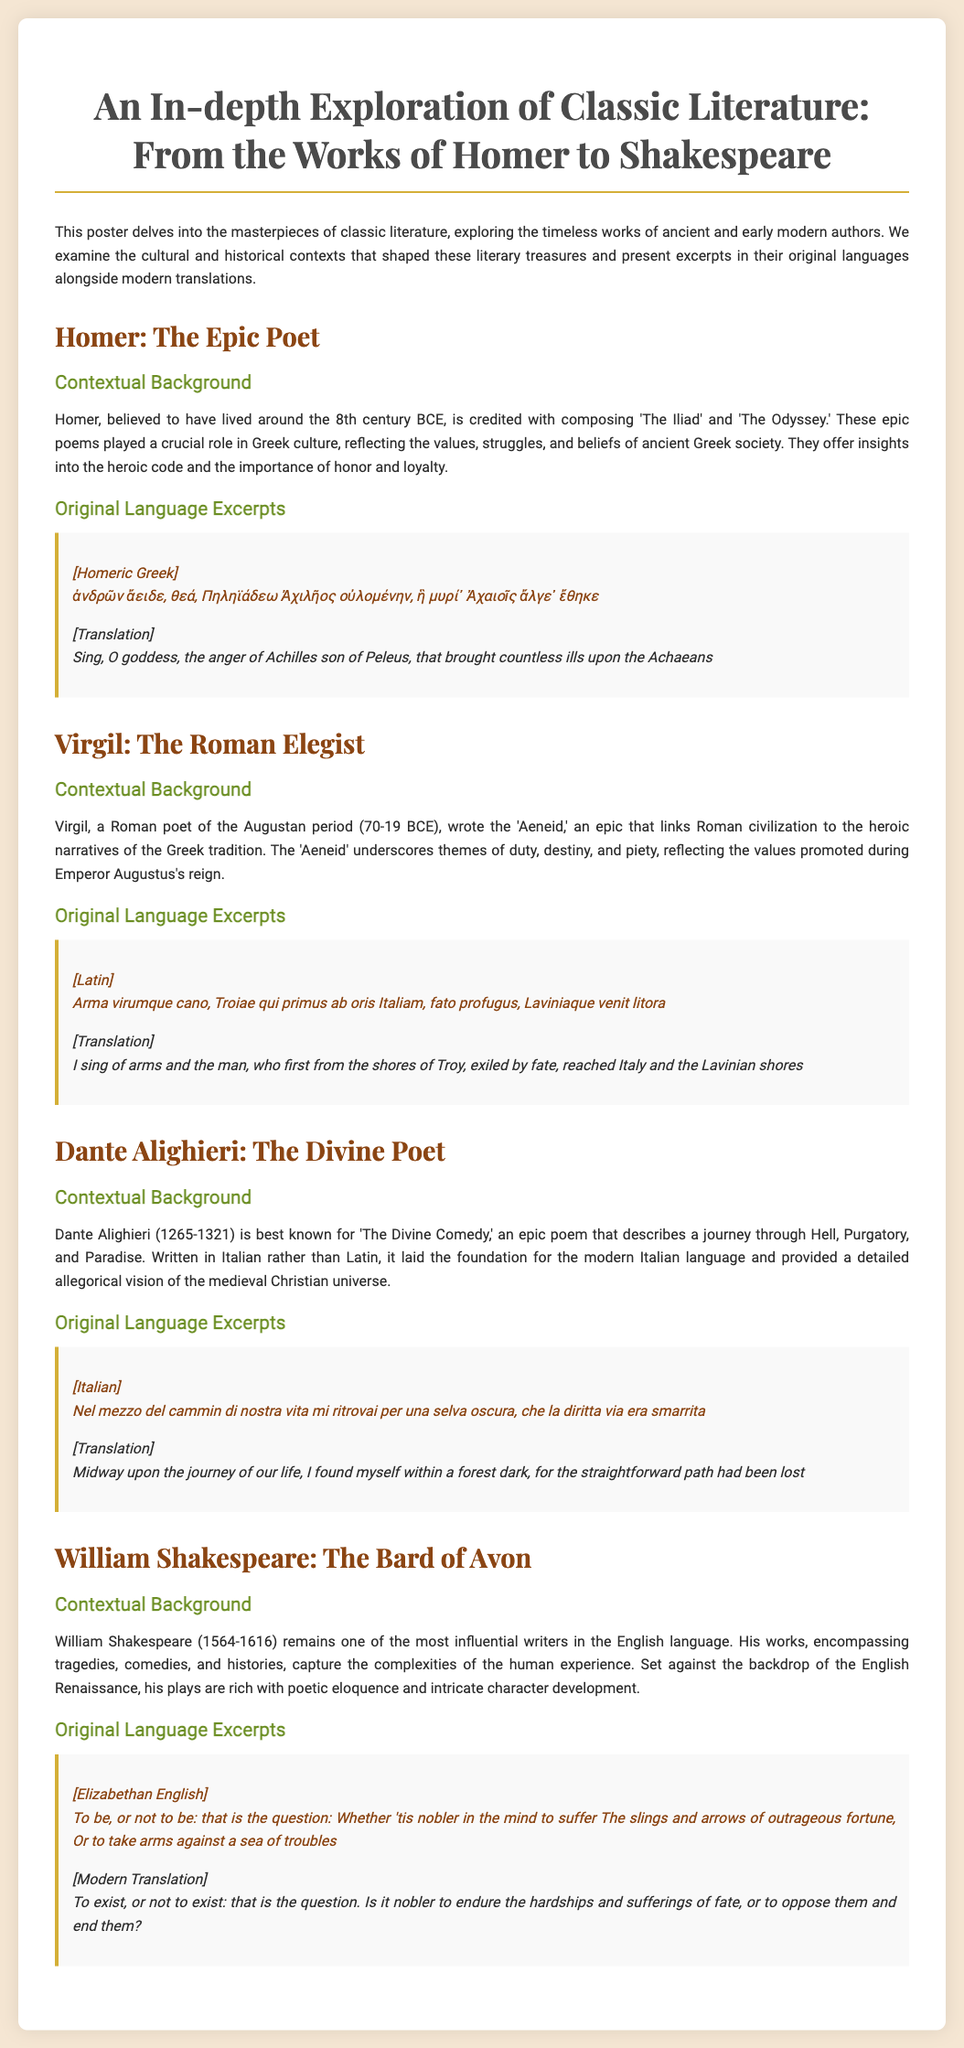What is the title of the poster? The title of the poster is presented at the top and introduces the exploration of classic literature.
Answer: An In-depth Exploration of Classic Literature: From the Works of Homer to Shakespeare In which century is Homer believed to have lived? The poster provides the contextual background for Homer, mentioning that he lived around the 8th century BCE.
Answer: 8th century BCE Which epic poems are attributed to Homer? The poster lists the works of Homer, highlighting specific epic poems that he composed.
Answer: The Iliad and The Odyssey What is the central theme of Virgil's 'Aeneid'? The contextual background for Virgil discusses key themes present in his work, including duty and destiny.
Answer: Duty, destiny, and piety Which language did Dante Alighieri write in? The section about Dante specifies that he wrote his masterpiece in Italian rather than Latin.
Answer: Italian What is a well-known quote from Shakespeare included in the poster? The section discussing Shakespeare includes a famous line that exemplifies his style and content.
Answer: To be, or not to be: that is the question What year marks the death of William Shakespeare? The contextual background for Shakespeare provides his birth and death dates so the calculation of his death year can be derived.
Answer: 1616 Which poetic structure does 
Homer's work reflect? The contextual background discusses the heroic code reflected in Homer's epics, describing their significance in ancient Greek culture.
Answer: Heroic code 